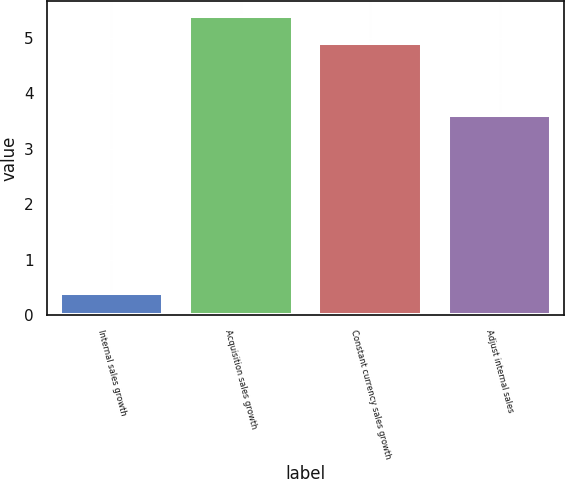Convert chart to OTSL. <chart><loc_0><loc_0><loc_500><loc_500><bar_chart><fcel>Internal sales growth<fcel>Acquisition sales growth<fcel>Constant currency sales growth<fcel>Adjust internal sales<nl><fcel>0.4<fcel>5.39<fcel>4.9<fcel>3.6<nl></chart> 